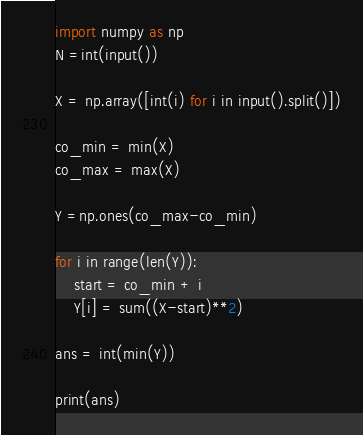<code> <loc_0><loc_0><loc_500><loc_500><_Python_>import numpy as np
N =int(input())

X = np.array([int(i) for i in input().split()])

co_min = min(X)
co_max = max(X)

Y =np.ones(co_max-co_min)

for i in range(len(Y)):
    start = co_min + i
    Y[i] = sum((X-start)**2)
    
ans = int(min(Y))

print(ans)</code> 